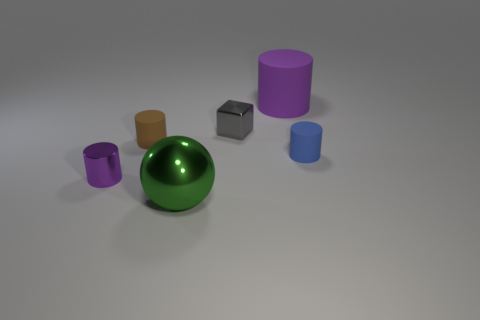Which objects in this image could be used to hold liquids? The objects that seem capable of holding liquids are the cylinders due to their shape, specifically the small purple cylinder, the large purple cylinder, and the two blue cylinders, assuming they are hollow with open tops. 